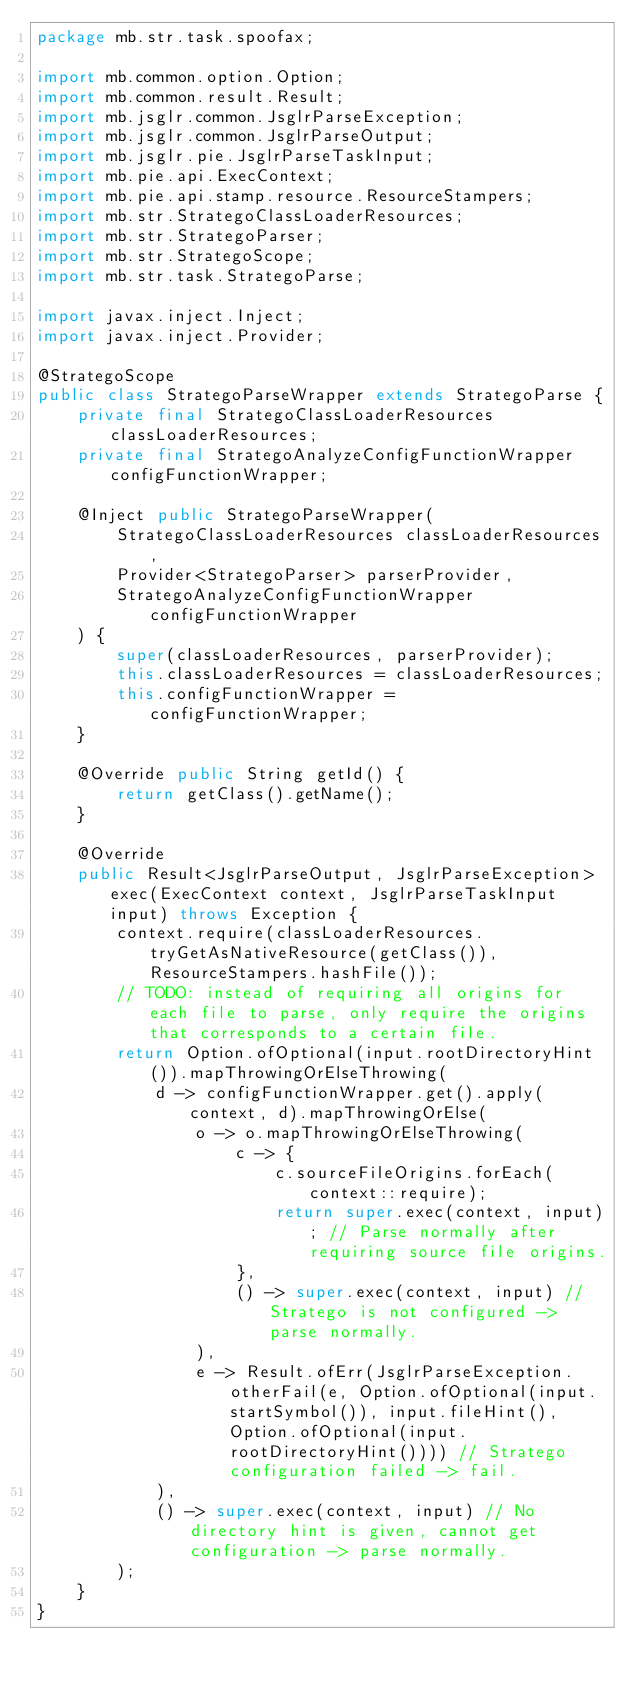<code> <loc_0><loc_0><loc_500><loc_500><_Java_>package mb.str.task.spoofax;

import mb.common.option.Option;
import mb.common.result.Result;
import mb.jsglr.common.JsglrParseException;
import mb.jsglr.common.JsglrParseOutput;
import mb.jsglr.pie.JsglrParseTaskInput;
import mb.pie.api.ExecContext;
import mb.pie.api.stamp.resource.ResourceStampers;
import mb.str.StrategoClassLoaderResources;
import mb.str.StrategoParser;
import mb.str.StrategoScope;
import mb.str.task.StrategoParse;

import javax.inject.Inject;
import javax.inject.Provider;

@StrategoScope
public class StrategoParseWrapper extends StrategoParse {
    private final StrategoClassLoaderResources classLoaderResources;
    private final StrategoAnalyzeConfigFunctionWrapper configFunctionWrapper;

    @Inject public StrategoParseWrapper(
        StrategoClassLoaderResources classLoaderResources,
        Provider<StrategoParser> parserProvider,
        StrategoAnalyzeConfigFunctionWrapper configFunctionWrapper
    ) {
        super(classLoaderResources, parserProvider);
        this.classLoaderResources = classLoaderResources;
        this.configFunctionWrapper = configFunctionWrapper;
    }

    @Override public String getId() {
        return getClass().getName();
    }

    @Override
    public Result<JsglrParseOutput, JsglrParseException> exec(ExecContext context, JsglrParseTaskInput input) throws Exception {
        context.require(classLoaderResources.tryGetAsNativeResource(getClass()), ResourceStampers.hashFile());
        // TODO: instead of requiring all origins for each file to parse, only require the origins that corresponds to a certain file.
        return Option.ofOptional(input.rootDirectoryHint()).mapThrowingOrElseThrowing(
            d -> configFunctionWrapper.get().apply(context, d).mapThrowingOrElse(
                o -> o.mapThrowingOrElseThrowing(
                    c -> {
                        c.sourceFileOrigins.forEach(context::require);
                        return super.exec(context, input); // Parse normally after requiring source file origins.
                    },
                    () -> super.exec(context, input) // Stratego is not configured -> parse normally.
                ),
                e -> Result.ofErr(JsglrParseException.otherFail(e, Option.ofOptional(input.startSymbol()), input.fileHint(), Option.ofOptional(input.rootDirectoryHint()))) // Stratego configuration failed -> fail.
            ),
            () -> super.exec(context, input) // No directory hint is given, cannot get configuration -> parse normally.
        );
    }
}
</code> 